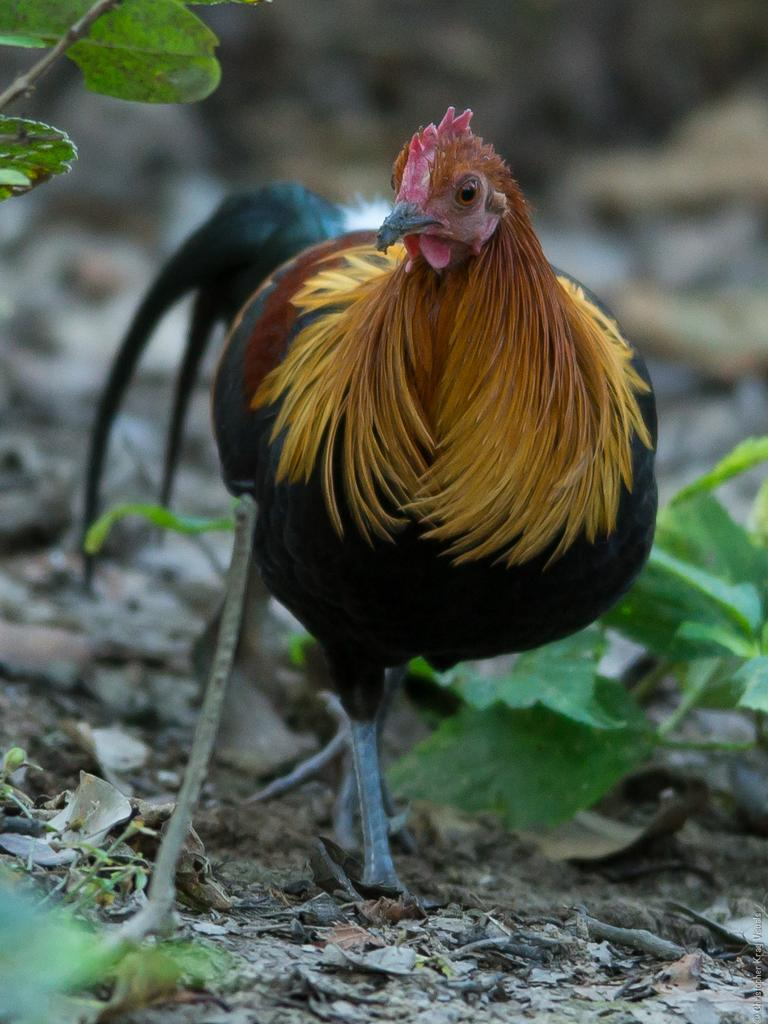What animal can be seen in the image? There is a hen in the image. What can be seen beneath the hen? The ground is visible in the image, and there are leaves on the ground. What type of vegetation is present in the image? There are plants in the image. How would you describe the background of the image? The background of the image is blurred. What type of fork is being used by the yak in the image? There is no yak or fork present in the image. 